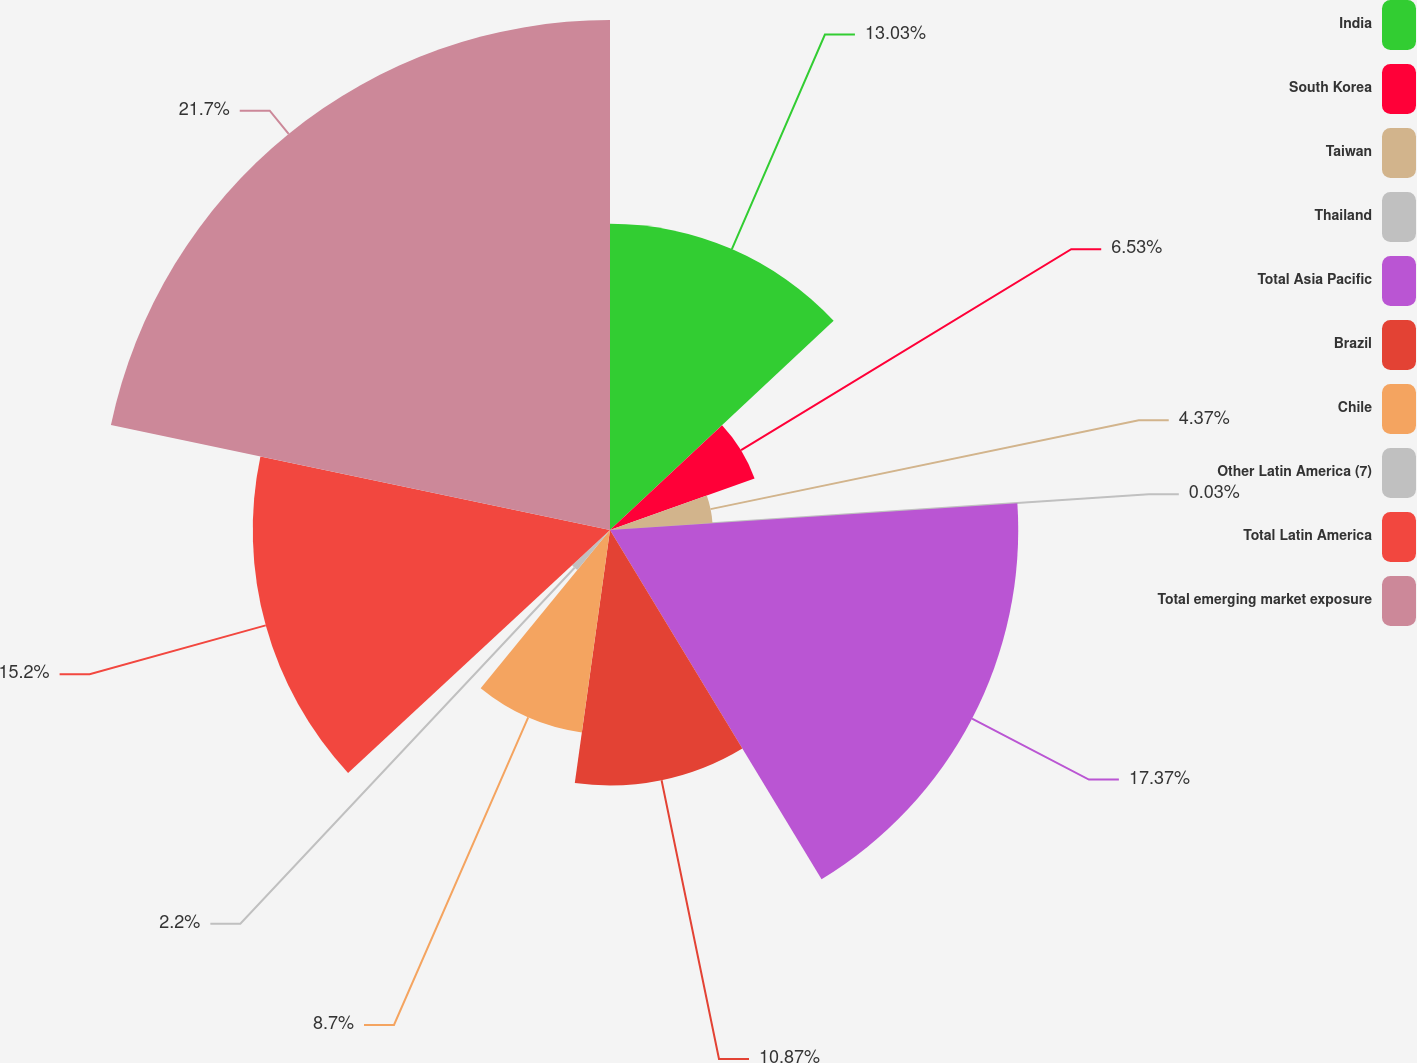<chart> <loc_0><loc_0><loc_500><loc_500><pie_chart><fcel>India<fcel>South Korea<fcel>Taiwan<fcel>Thailand<fcel>Total Asia Pacific<fcel>Brazil<fcel>Chile<fcel>Other Latin America (7)<fcel>Total Latin America<fcel>Total emerging market exposure<nl><fcel>13.03%<fcel>6.53%<fcel>4.37%<fcel>0.03%<fcel>17.37%<fcel>10.87%<fcel>8.7%<fcel>2.2%<fcel>15.2%<fcel>21.7%<nl></chart> 